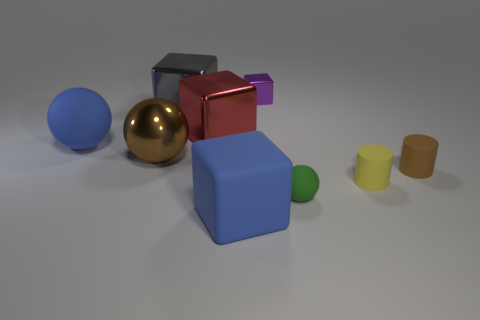What color is the matte ball that is behind the brown object on the right side of the blue matte cube?
Provide a succinct answer. Blue. The rubber object that is the same size as the blue block is what color?
Offer a very short reply. Blue. What number of metal things are red things or tiny objects?
Keep it short and to the point. 2. There is a small yellow rubber thing to the right of the large brown ball; what number of rubber cylinders are to the right of it?
Give a very brief answer. 1. The rubber object that is the same color as the large metal sphere is what size?
Your answer should be very brief. Small. How many things are shiny cubes or things behind the blue block?
Your response must be concise. 8. Is there a large purple cube made of the same material as the small sphere?
Provide a short and direct response. No. How many tiny objects are both to the left of the yellow rubber cylinder and behind the small yellow cylinder?
Your response must be concise. 1. What is the material of the ball that is on the left side of the large metal sphere?
Provide a succinct answer. Rubber. There is a red object that is made of the same material as the big brown sphere; what size is it?
Ensure brevity in your answer.  Large. 